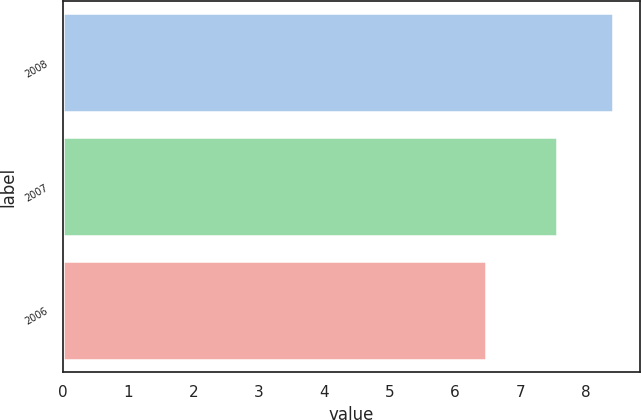<chart> <loc_0><loc_0><loc_500><loc_500><bar_chart><fcel>2008<fcel>2007<fcel>2006<nl><fcel>8.42<fcel>7.56<fcel>6.48<nl></chart> 